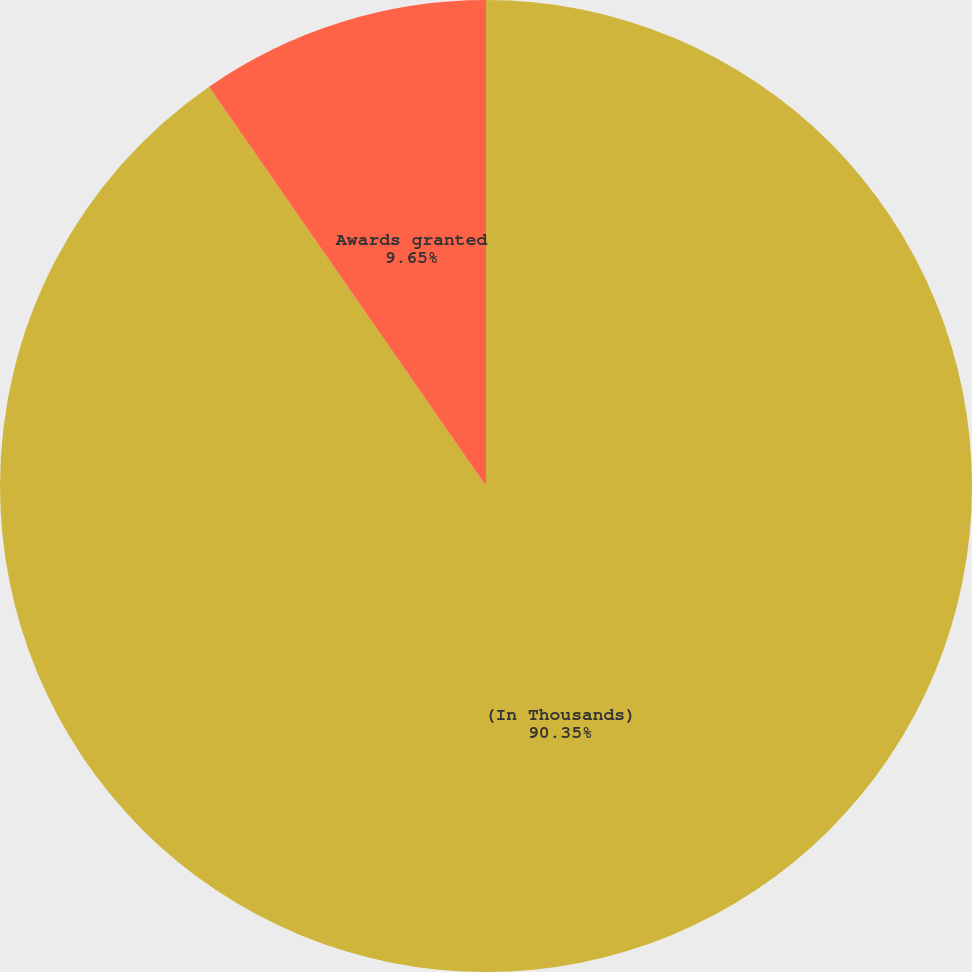Convert chart. <chart><loc_0><loc_0><loc_500><loc_500><pie_chart><fcel>(In Thousands)<fcel>Awards granted<nl><fcel>90.35%<fcel>9.65%<nl></chart> 